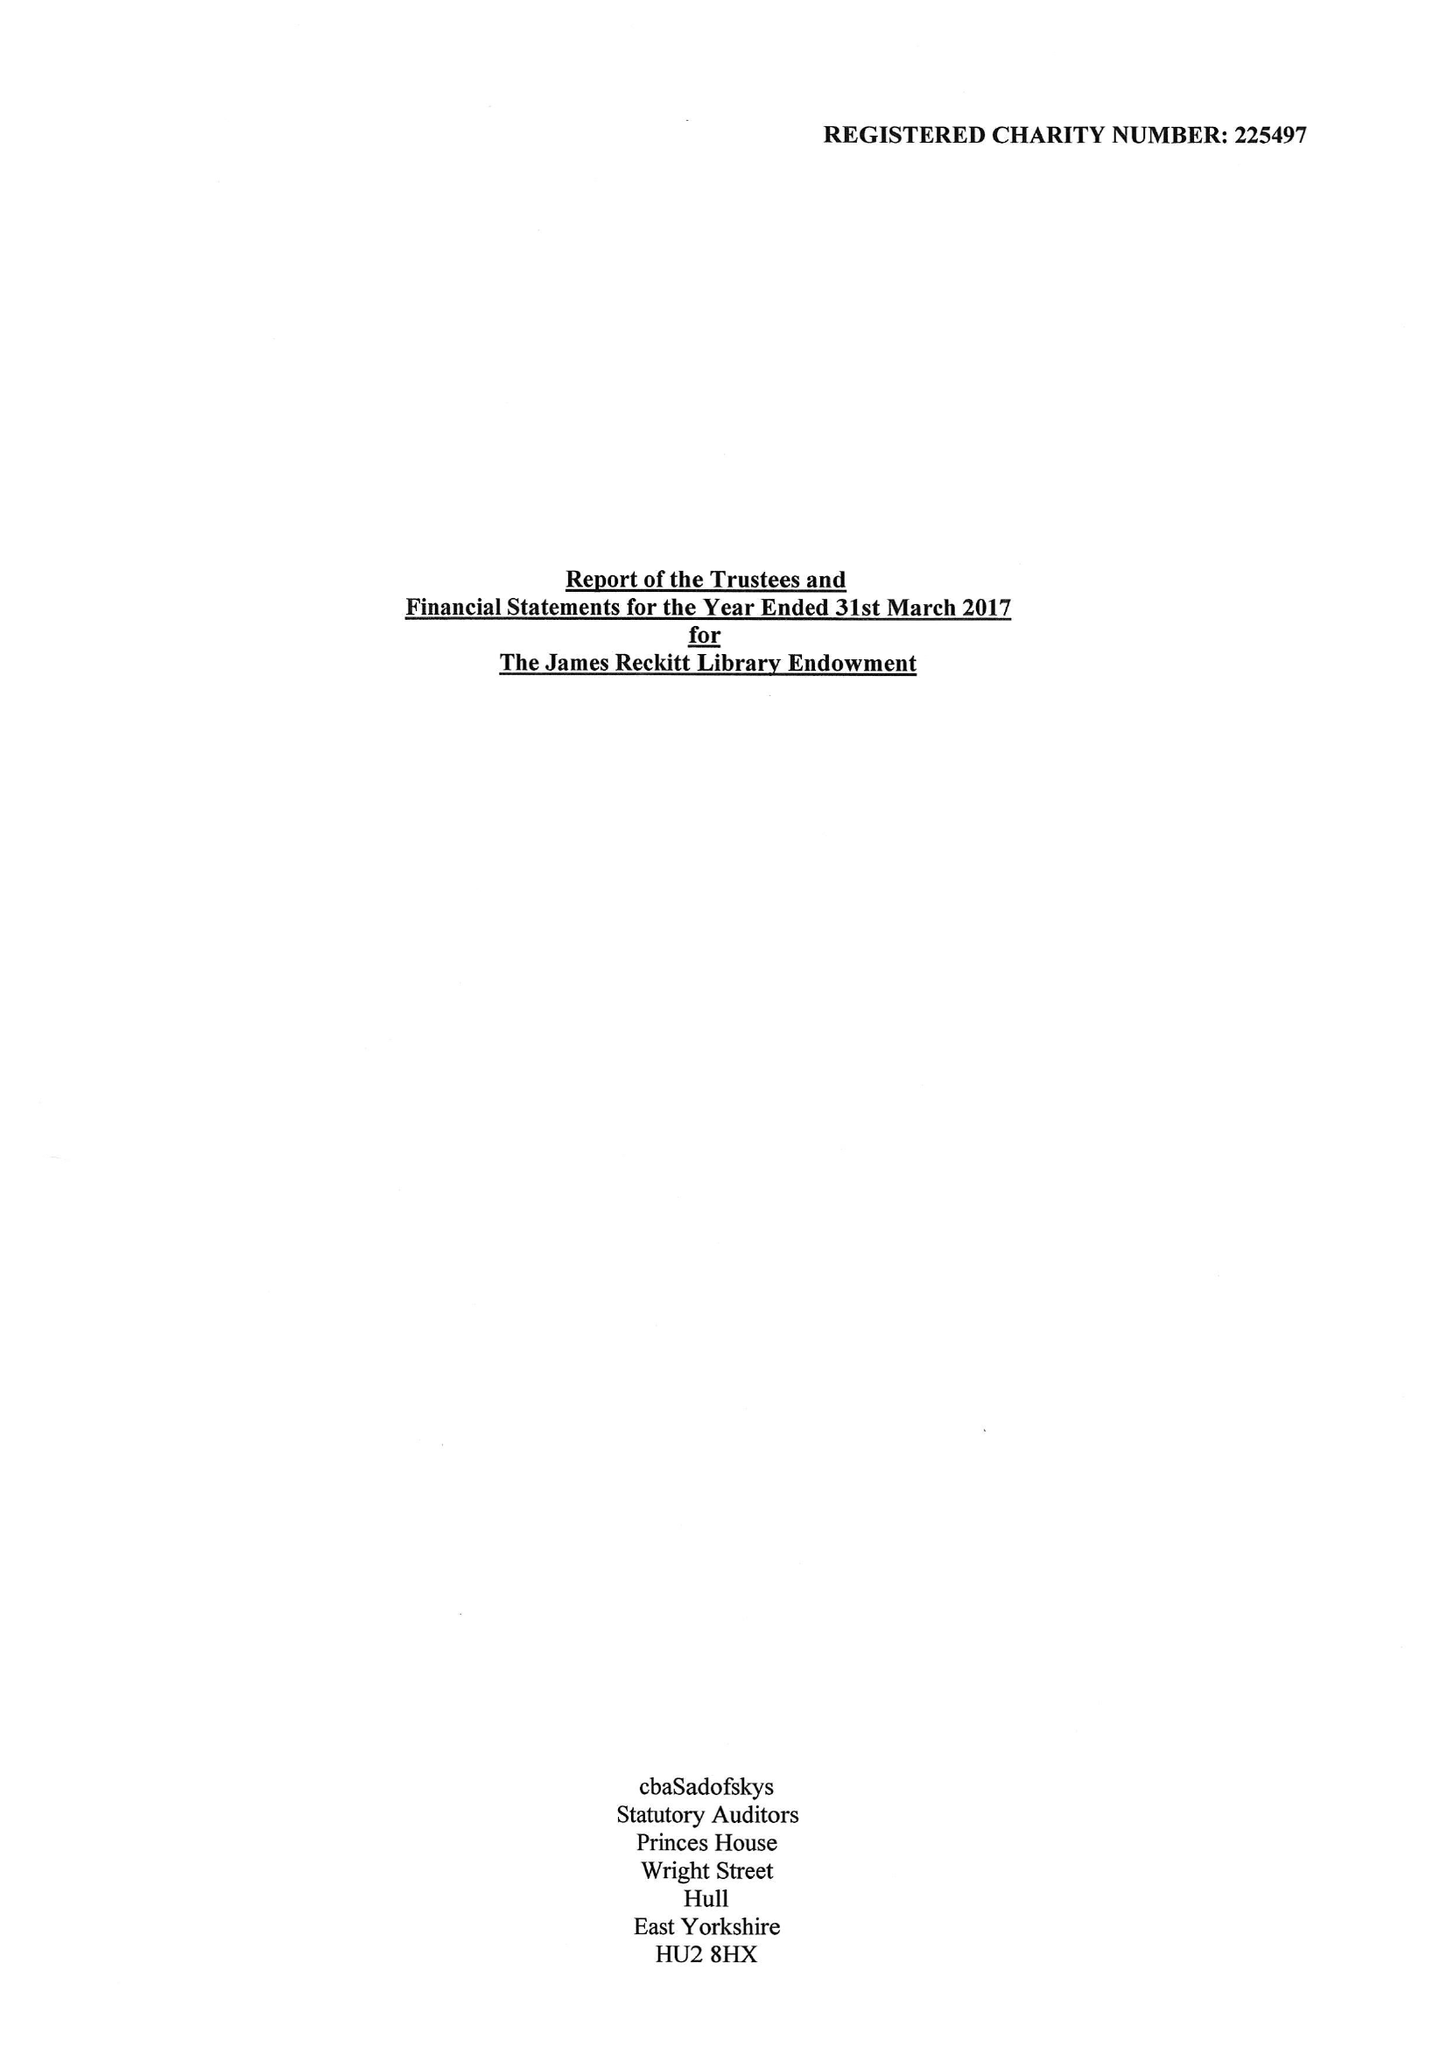What is the value for the address__street_line?
Answer the question using a single word or phrase. GUILDHALL ROAD 